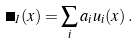Convert formula to latex. <formula><loc_0><loc_0><loc_500><loc_500>\Psi _ { 1 } ( x ) = \sum _ { i } a _ { i } u _ { i } ( x ) \, .</formula> 